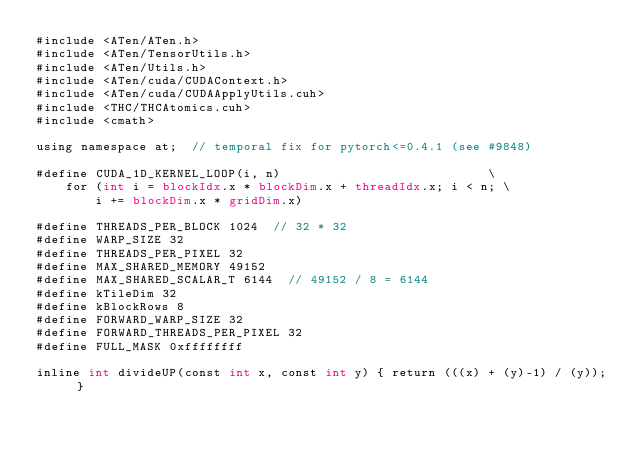Convert code to text. <code><loc_0><loc_0><loc_500><loc_500><_Cuda_>#include <ATen/ATen.h>
#include <ATen/TensorUtils.h>
#include <ATen/Utils.h>
#include <ATen/cuda/CUDAContext.h>
#include <ATen/cuda/CUDAApplyUtils.cuh>
#include <THC/THCAtomics.cuh>
#include <cmath>

using namespace at;  // temporal fix for pytorch<=0.4.1 (see #9848)

#define CUDA_1D_KERNEL_LOOP(i, n)                            \
    for (int i = blockIdx.x * blockDim.x + threadIdx.x; i < n; \
        i += blockDim.x * gridDim.x)

#define THREADS_PER_BLOCK 1024  // 32 * 32
#define WARP_SIZE 32
#define THREADS_PER_PIXEL 32
#define MAX_SHARED_MEMORY 49152
#define MAX_SHARED_SCALAR_T 6144  // 49152 / 8 = 6144
#define kTileDim 32
#define kBlockRows 8
#define FORWARD_WARP_SIZE 32
#define FORWARD_THREADS_PER_PIXEL 32
#define FULL_MASK 0xffffffff

inline int divideUP(const int x, const int y) { return (((x) + (y)-1) / (y)); }
</code> 